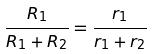Convert formula to latex. <formula><loc_0><loc_0><loc_500><loc_500>\frac { R _ { 1 } } { R _ { 1 } + R _ { 2 } } = \frac { r _ { 1 } } { r _ { 1 } + r _ { 2 } }</formula> 